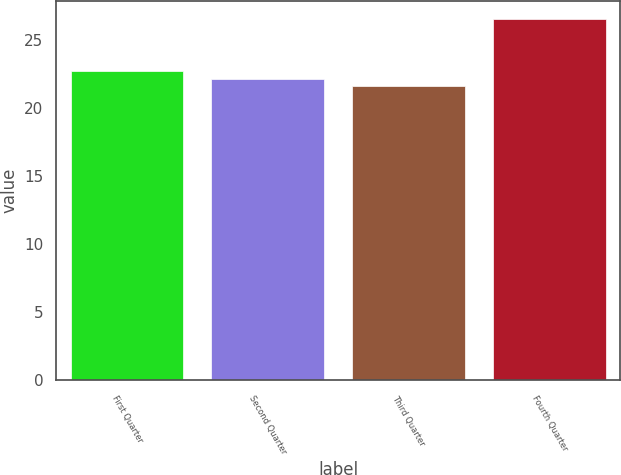Convert chart. <chart><loc_0><loc_0><loc_500><loc_500><bar_chart><fcel>First Quarter<fcel>Second Quarter<fcel>Third Quarter<fcel>Fourth Quarter<nl><fcel>22.71<fcel>22.13<fcel>21.64<fcel>26.53<nl></chart> 